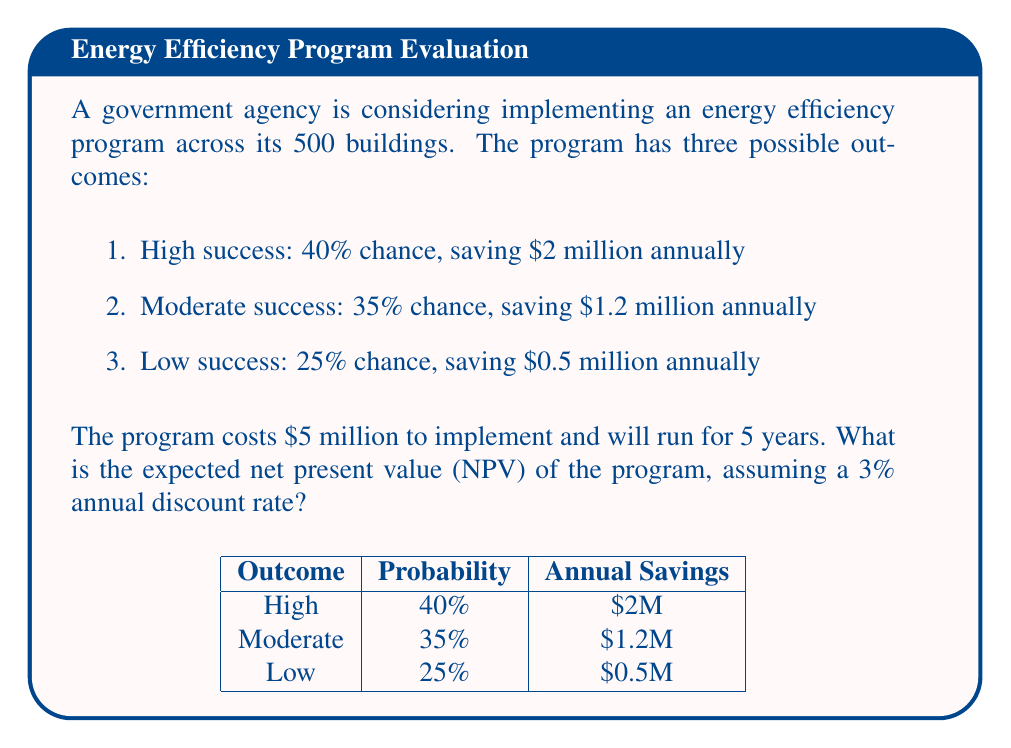Can you solve this math problem? Let's approach this step-by-step:

1) First, we need to calculate the expected annual savings:

   $E(\text{annual savings}) = 0.40 \cdot \$2\text{M} + 0.35 \cdot \$1.2\text{M} + 0.25 \cdot \$0.5\text{M}$
   $= \$0.8\text{M} + \$0.42\text{M} + \$0.125\text{M} = \$1.345\text{M}$

2) Now, we need to calculate the present value of these savings over 5 years with a 3% discount rate. We can use the present value annuity formula:

   $PV = A \cdot \frac{1 - (1+r)^{-n}}{r}$

   Where $A$ is the annual payment, $r$ is the discount rate, and $n$ is the number of years.

3) Plugging in our values:

   $PV = \$1.345\text{M} \cdot \frac{1 - (1+0.03)^{-5}}{0.03}$

4) Calculating this:

   $PV = \$1.345\text{M} \cdot 4.5797 = \$6.1597\text{M}$

5) The NPV is the present value of all cash flows, including the initial investment:

   $NPV = -\$5\text{M} + \$6.1597\text{M} = \$1.1597\text{M}$

Therefore, the expected NPV of the program is approximately $1.16 million.
Answer: $\$1.16$ million 